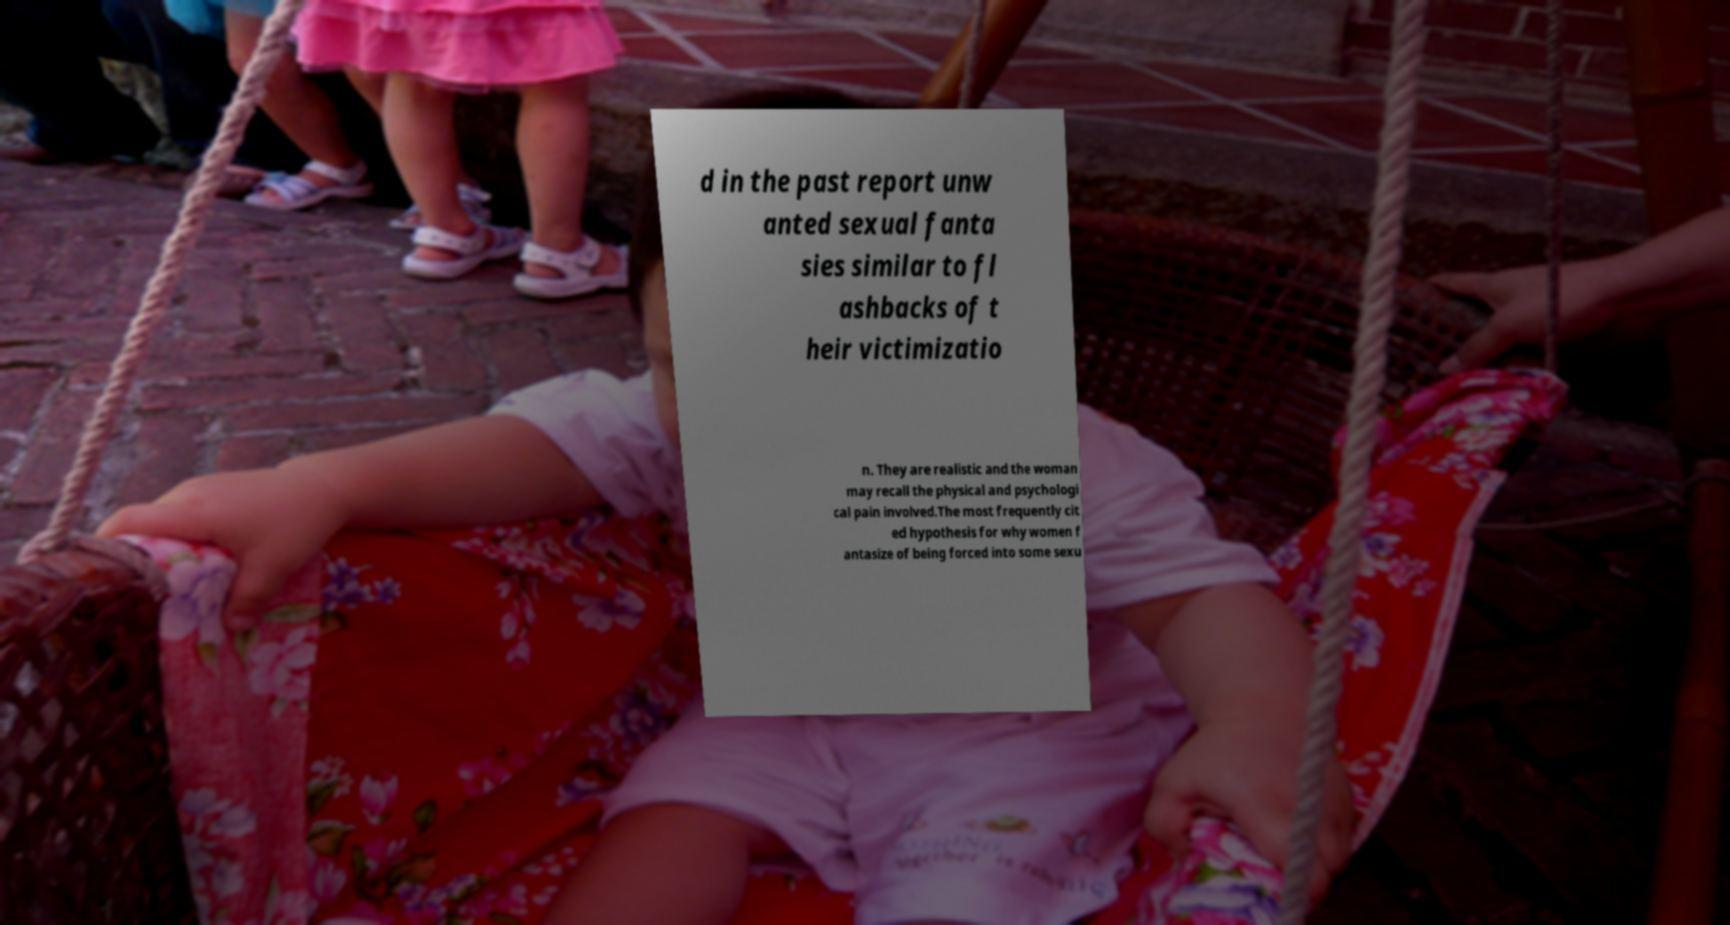Can you accurately transcribe the text from the provided image for me? d in the past report unw anted sexual fanta sies similar to fl ashbacks of t heir victimizatio n. They are realistic and the woman may recall the physical and psychologi cal pain involved.The most frequently cit ed hypothesis for why women f antasize of being forced into some sexu 